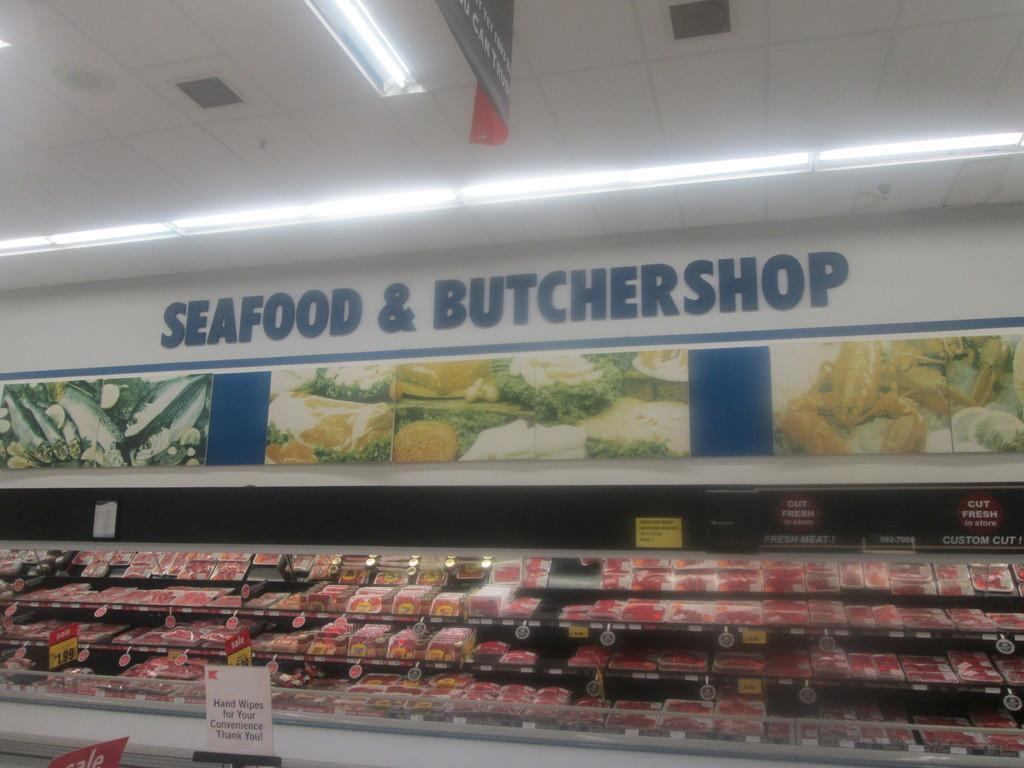<image>
Relay a brief, clear account of the picture shown. an interior of a grocery store for the Seafood & Butcher shop 